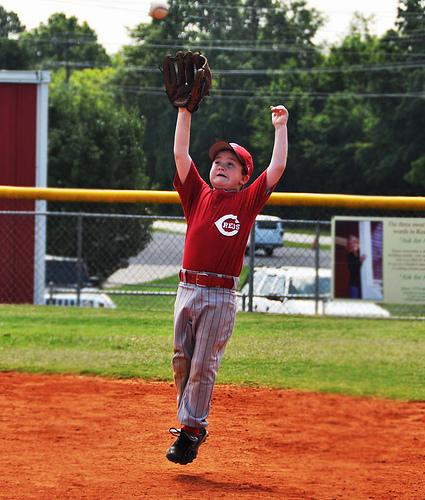What is the outcome if the ball went over the fence? homerun 